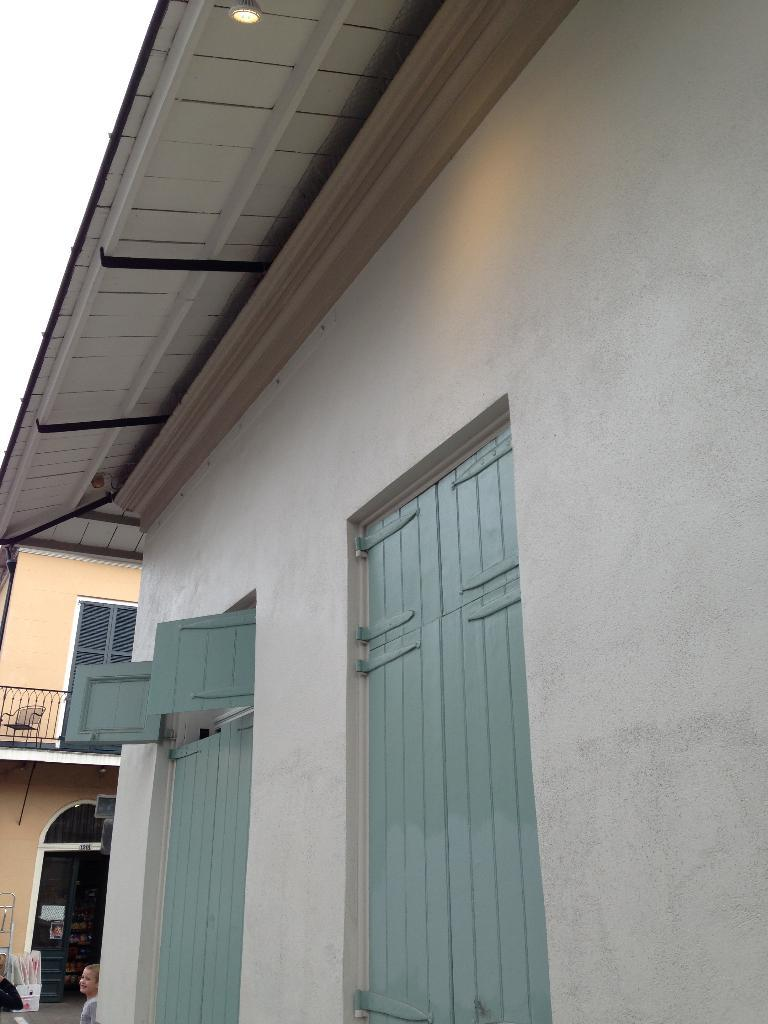What type of structures are present in the image? There are buildings in the image. Can you describe the light at the top of the image? There is a light at the top of the image. What is located at the bottom of the image? There is a kid at the bottom of the image. What type of butter can be seen melting in the shade in the image? There is no butter or shade present in the image. 